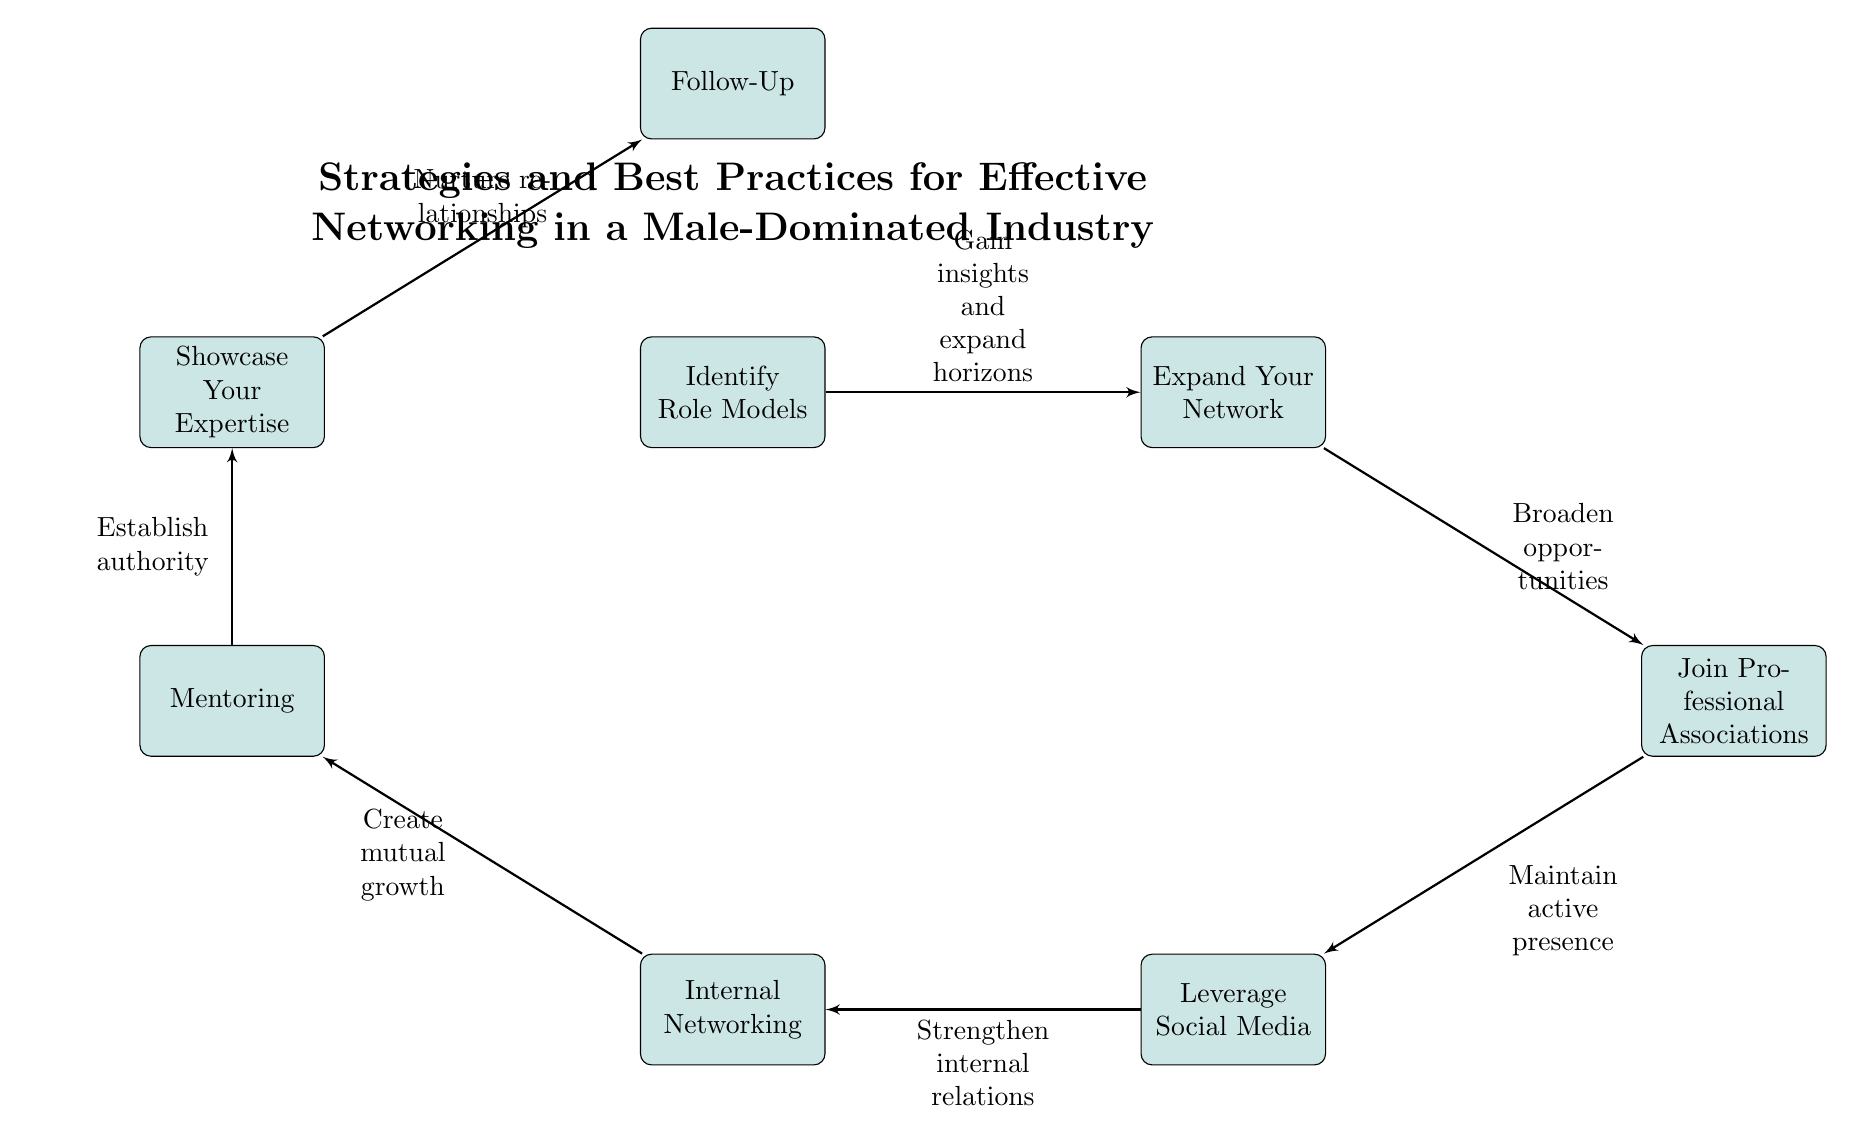What is the first strategy mentioned in the diagram? The first strategy is represented by the top-most node labeled "Identify Role Models." This is the initial block in the flow of strategies.
Answer: Identify Role Models How many total strategies are illustrated in the diagram? By counting the number of blocks, we see there are 8 distinct strategies mentioned in the diagram.
Answer: 8 What is the relationship between "Leverage Social Media" and "Join Professional Associations"? "Leverage Social Media" is directly below "Join Professional Associations," indicating a sequential flow where leveraging social media comes after joining associations.
Answer: Maintain active presence Which strategy is placed directly above "Follow-Up"? "Showcase Your Expertise" is placed directly above "Follow-Up," indicating it precedes the follow-up stage in the networking process.
Answer: Showcase Your Expertise What is the purpose of "Internal Networking"? The purpose is indicated by the text connected to it, stating "Strengthen internal relations," which suggests it aims to improve collaboration within the organization.
Answer: Strengthen internal relations What is the final step in the networking strategies? The final step is represented by "Follow-Up," which is the bottom-most block in the diagram and signifies the last action to be taken after nurturing relationships.
Answer: Follow-Up What does "Mentoring" aim to create according to the diagram? According to the text associated with the "Mentoring" block, it aims to "Create mutual growth" which implies a benefit for both the mentor and mentee.
Answer: Create mutual growth What comes after "Expand Your Network" in the flow? After "Expand Your Network," the next strategy indicated is "Join Professional Associations," showing a logical progression from expanding connections to formalizing them through professional groups.
Answer: Join Professional Associations What does "Showcase Your Expertise" contribute to networking? "Showcase Your Expertise" establishes authority, aligning with the purpose of affirming one’s credibility in the industry, as indicated by the text connected to it.
Answer: Establish authority 